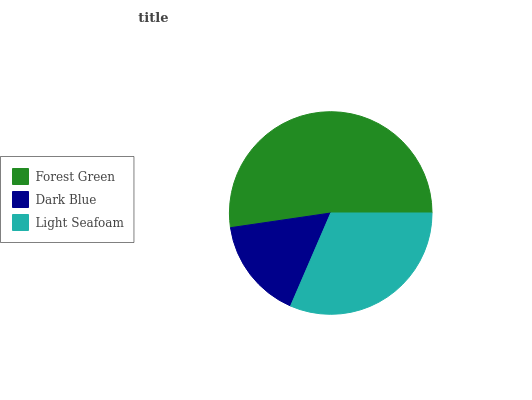Is Dark Blue the minimum?
Answer yes or no. Yes. Is Forest Green the maximum?
Answer yes or no. Yes. Is Light Seafoam the minimum?
Answer yes or no. No. Is Light Seafoam the maximum?
Answer yes or no. No. Is Light Seafoam greater than Dark Blue?
Answer yes or no. Yes. Is Dark Blue less than Light Seafoam?
Answer yes or no. Yes. Is Dark Blue greater than Light Seafoam?
Answer yes or no. No. Is Light Seafoam less than Dark Blue?
Answer yes or no. No. Is Light Seafoam the high median?
Answer yes or no. Yes. Is Light Seafoam the low median?
Answer yes or no. Yes. Is Dark Blue the high median?
Answer yes or no. No. Is Dark Blue the low median?
Answer yes or no. No. 